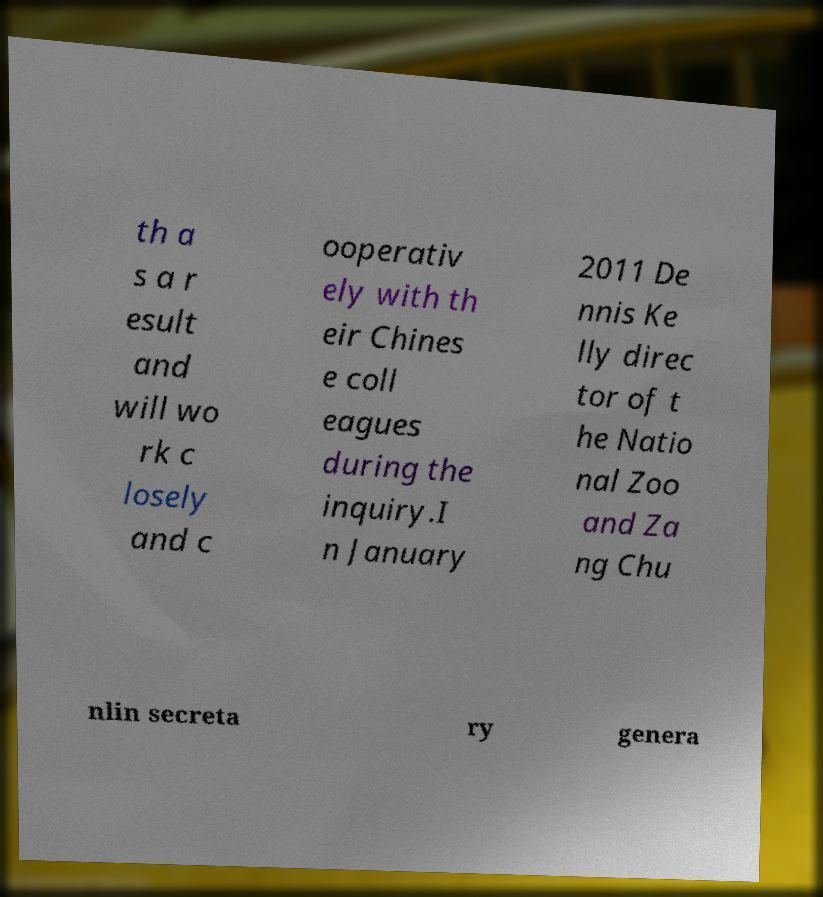There's text embedded in this image that I need extracted. Can you transcribe it verbatim? th a s a r esult and will wo rk c losely and c ooperativ ely with th eir Chines e coll eagues during the inquiry.I n January 2011 De nnis Ke lly direc tor of t he Natio nal Zoo and Za ng Chu nlin secreta ry genera 